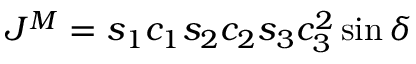<formula> <loc_0><loc_0><loc_500><loc_500>J ^ { M } = s _ { 1 } c _ { 1 } s _ { 2 } c _ { 2 } s _ { 3 } c _ { 3 } ^ { 2 } \sin \delta</formula> 